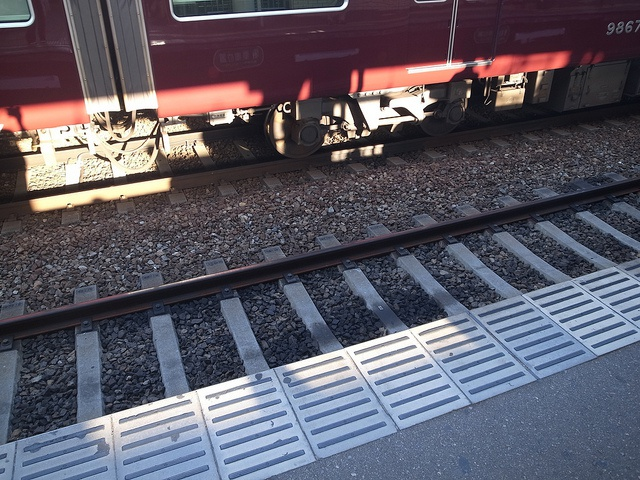Describe the objects in this image and their specific colors. I can see a train in black, gray, and ivory tones in this image. 